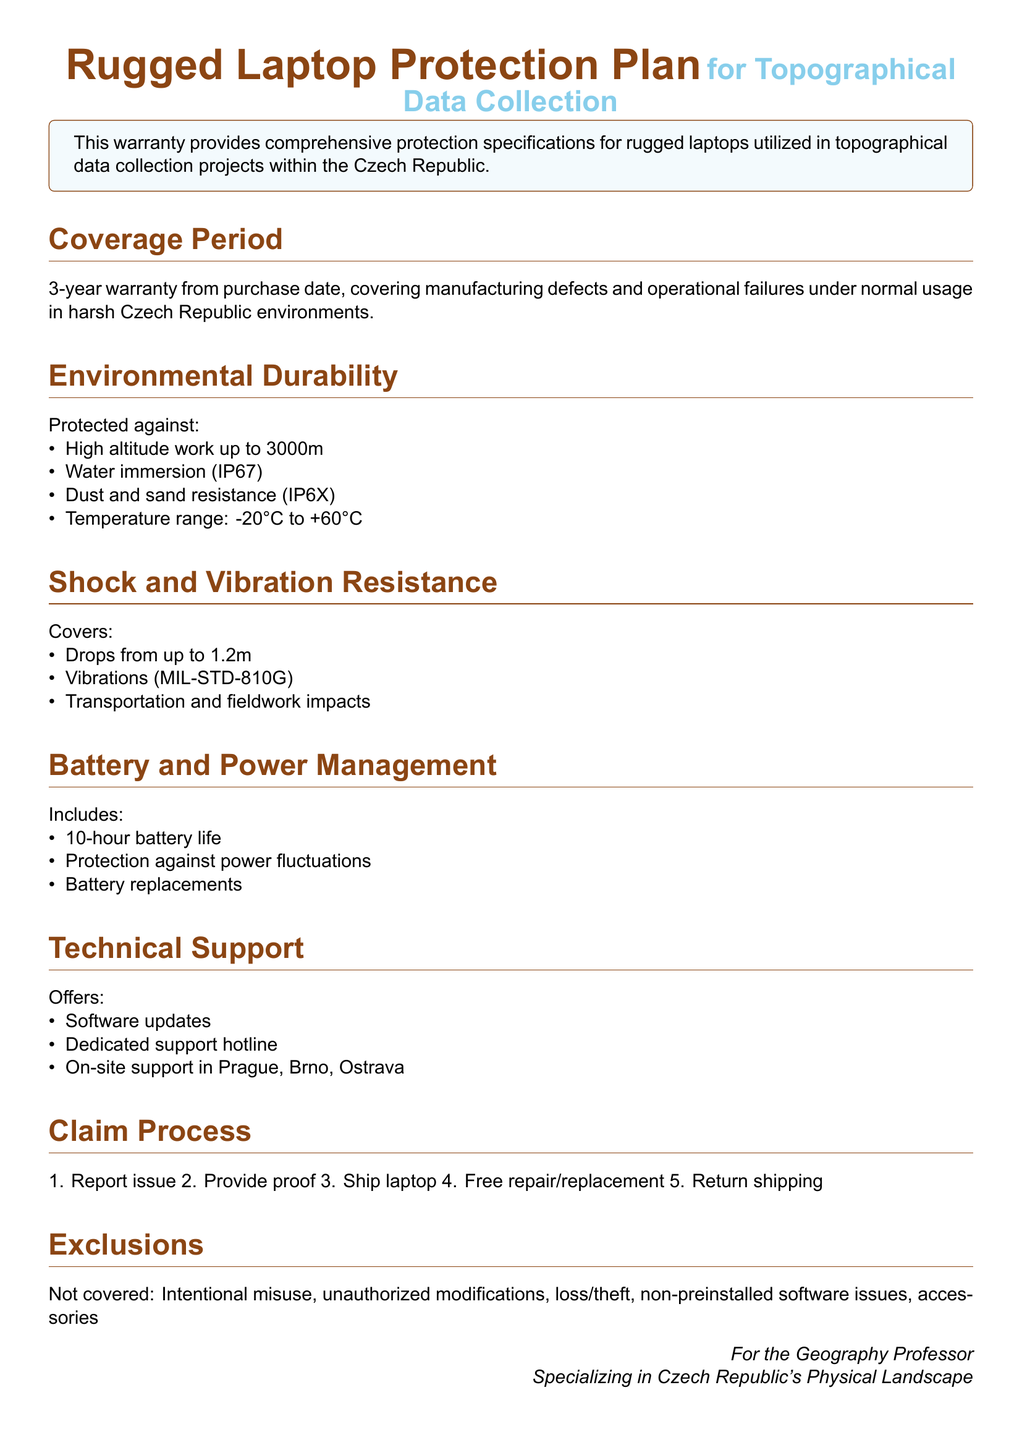What is the coverage period of the warranty? The coverage period is specified in years, indicating how long the warranty will be valid from the purchase date.
Answer: 3-year What types of environmental durability are covered? The document lists specific protections against environmental factors, detailing each aspect covered under durability.
Answer: High altitude work, water immersion, dust and sand resistance, temperature range What is the maximum temperature range the laptop can operate in? The document mentions a specific range of temperatures that the laptop is designed to withstand during use.
Answer: -20°C to +60°C How high can the laptop withstand altitude work? The warranty specifies the maximum altitude the laptop can effectively function in for data collection activities.
Answer: 3000m What is the drop height protection for the rugged laptop? The document provides a specific height indicating from how far the laptop can safely drop without damage.
Answer: 1.2m What items are excluded from the warranty coverage? The warranty document explicitly lists situations or conditions that are not covered, which can be found in the exclusions section.
Answer: Intentional misuse, unauthorized modifications, loss, theft What is the battery life included in the plan? The warranty specifies the expected duration of battery life under standard operating conditions.
Answer: 10-hour What support options are provided? The document details various support options available to the user under the warranty conditions, highlighting the available services.
Answer: Software updates, dedicated support hotline, on-site support What is the first step in the claim process? The claim process in the document outlines a series of steps to follow when needing to file a warranty claim, starting with an action to be taken.
Answer: Report issue 